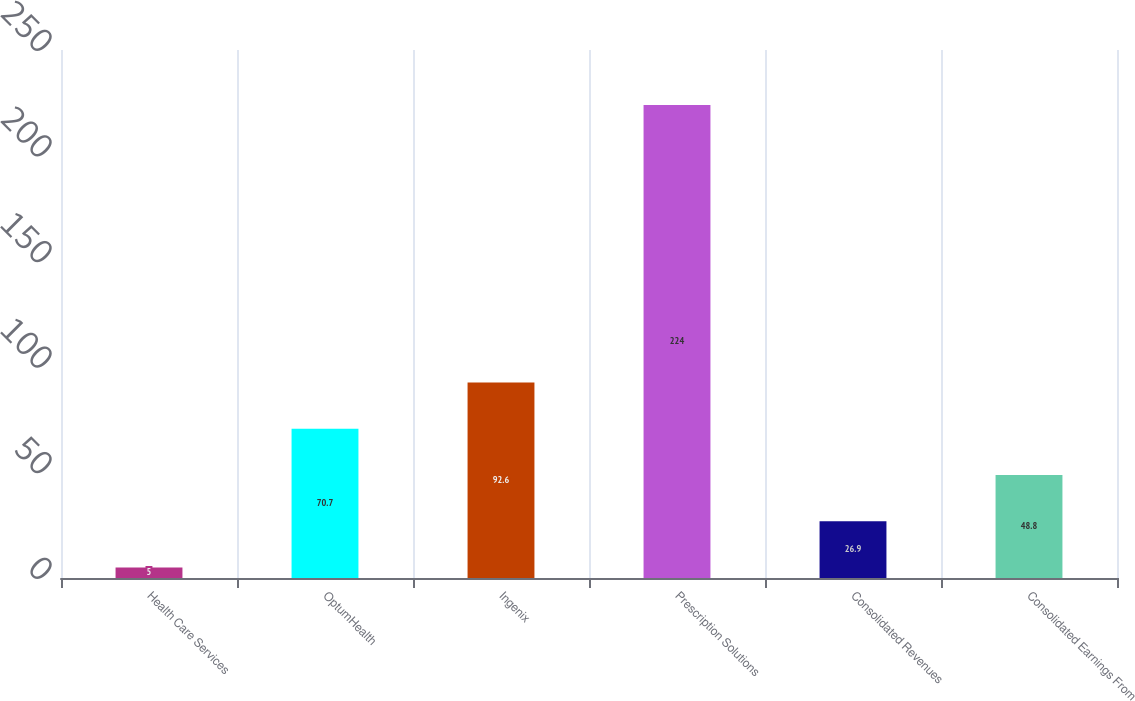<chart> <loc_0><loc_0><loc_500><loc_500><bar_chart><fcel>Health Care Services<fcel>OptumHealth<fcel>Ingenix<fcel>Prescription Solutions<fcel>Consolidated Revenues<fcel>Consolidated Earnings From<nl><fcel>5<fcel>70.7<fcel>92.6<fcel>224<fcel>26.9<fcel>48.8<nl></chart> 